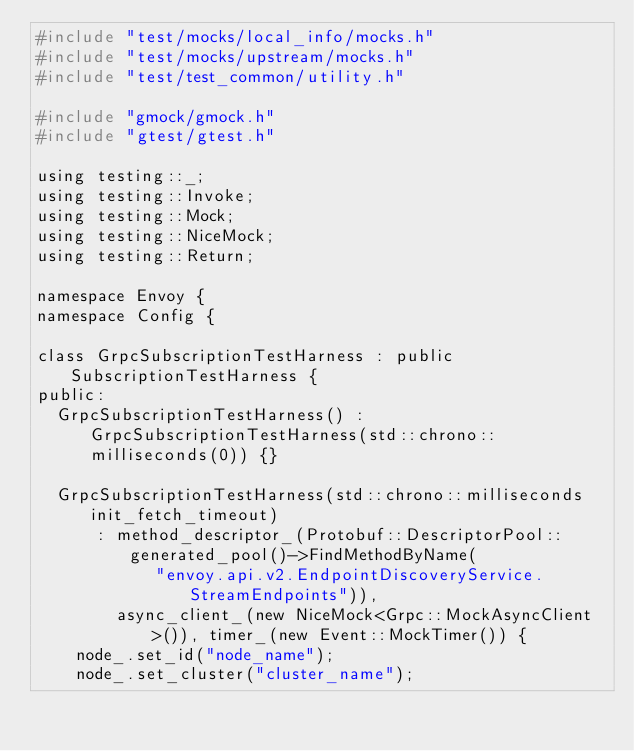<code> <loc_0><loc_0><loc_500><loc_500><_C_>#include "test/mocks/local_info/mocks.h"
#include "test/mocks/upstream/mocks.h"
#include "test/test_common/utility.h"

#include "gmock/gmock.h"
#include "gtest/gtest.h"

using testing::_;
using testing::Invoke;
using testing::Mock;
using testing::NiceMock;
using testing::Return;

namespace Envoy {
namespace Config {

class GrpcSubscriptionTestHarness : public SubscriptionTestHarness {
public:
  GrpcSubscriptionTestHarness() : GrpcSubscriptionTestHarness(std::chrono::milliseconds(0)) {}

  GrpcSubscriptionTestHarness(std::chrono::milliseconds init_fetch_timeout)
      : method_descriptor_(Protobuf::DescriptorPool::generated_pool()->FindMethodByName(
            "envoy.api.v2.EndpointDiscoveryService.StreamEndpoints")),
        async_client_(new NiceMock<Grpc::MockAsyncClient>()), timer_(new Event::MockTimer()) {
    node_.set_id("node_name");
    node_.set_cluster("cluster_name");</code> 